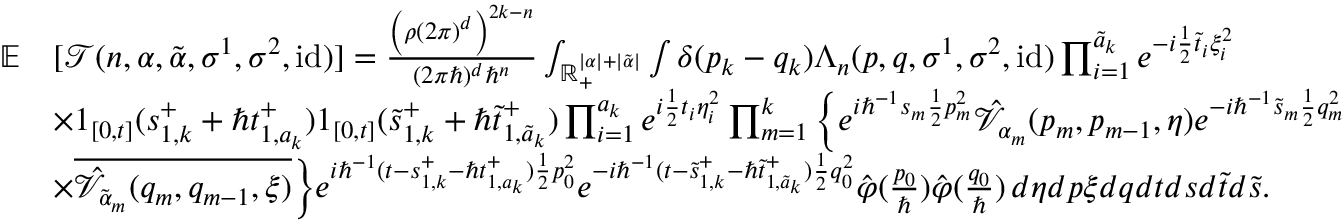<formula> <loc_0><loc_0><loc_500><loc_500>\begin{array} { r l } { \mathbb { E } } & { [ \mathcal { T } ( n , \alpha , \tilde { \alpha } , \sigma ^ { 1 } , \sigma ^ { 2 } , i d ) ] = \frac { \left ( \rho ( 2 \pi ) ^ { d } \right ) ^ { 2 k - n } } { ( 2 \pi \hbar { ) } ^ { d } \hbar { ^ } { n } } \int _ { \mathbb { R } _ { + } ^ { | \alpha | + | \tilde { \alpha } | } } \int \delta ( p _ { k } - q _ { k } ) \Lambda _ { n } ( p , q , \sigma ^ { 1 } , \sigma ^ { 2 } , i d ) \prod _ { i = 1 } ^ { \tilde { a } _ { k } } e ^ { - i \frac { 1 } { 2 } \tilde { t } _ { i } \xi _ { i } ^ { 2 } } } \\ & { \times 1 _ { [ 0 , t ] } ( s _ { 1 , k } ^ { + } + \hbar { t } _ { 1 , a _ { k } } ^ { + } ) 1 _ { [ 0 , t ] } ( \tilde { s } _ { 1 , k } ^ { + } + \hbar { \tilde } { t } _ { 1 , \tilde { a } _ { k } } ^ { + } ) \prod _ { i = 1 } ^ { a _ { k } } e ^ { i \frac { 1 } { 2 } t _ { i } \eta _ { i } ^ { 2 } } \prod _ { m = 1 } ^ { k } \left \{ e ^ { i \hbar { ^ } { - 1 } s _ { m } \frac { 1 } { 2 } p _ { m } ^ { 2 } } \hat { \mathcal { V } } _ { \alpha _ { m } } ( p _ { m } , p _ { m - 1 } , \eta ) e ^ { - i \hbar { ^ } { - 1 } \tilde { s } _ { m } \frac { 1 } { 2 } q _ { m } ^ { 2 } } } \\ & { \times \overline { { \hat { \mathcal { V } } _ { \tilde { \alpha } _ { m } } ( q _ { m } , q _ { m - 1 } , \xi ) } } \right \} e ^ { i \hbar { ^ } { - 1 } ( t - s _ { 1 , k } ^ { + } - \hbar { t } _ { 1 , a _ { k } } ^ { + } ) \frac { 1 } { 2 } p _ { 0 } ^ { 2 } } e ^ { - i \hbar { ^ } { - 1 } ( t - \tilde { s } _ { 1 , k } ^ { + } - \hbar { \tilde } { t } _ { 1 , \tilde { a } _ { k } } ^ { + } ) \frac { 1 } { 2 } q _ { 0 } ^ { 2 } } \hat { \varphi } ( \frac { p _ { 0 } } { } ) \hat { \varphi } ( \frac { q _ { 0 } } { } ) \, d \eta d p \xi d q d t d s d \tilde { t } d \tilde { s } . } \end{array}</formula> 